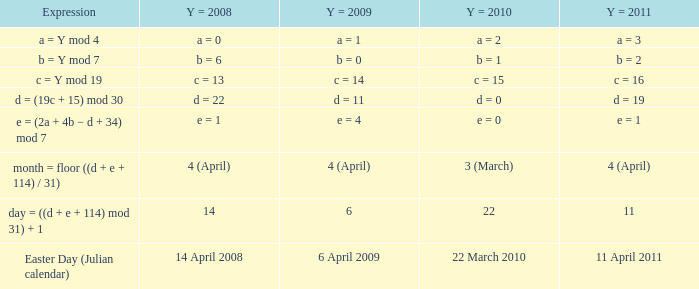What is the y = 2009 when the formula is month = floor ((d + e + 114) / 31)? 4 (April). 